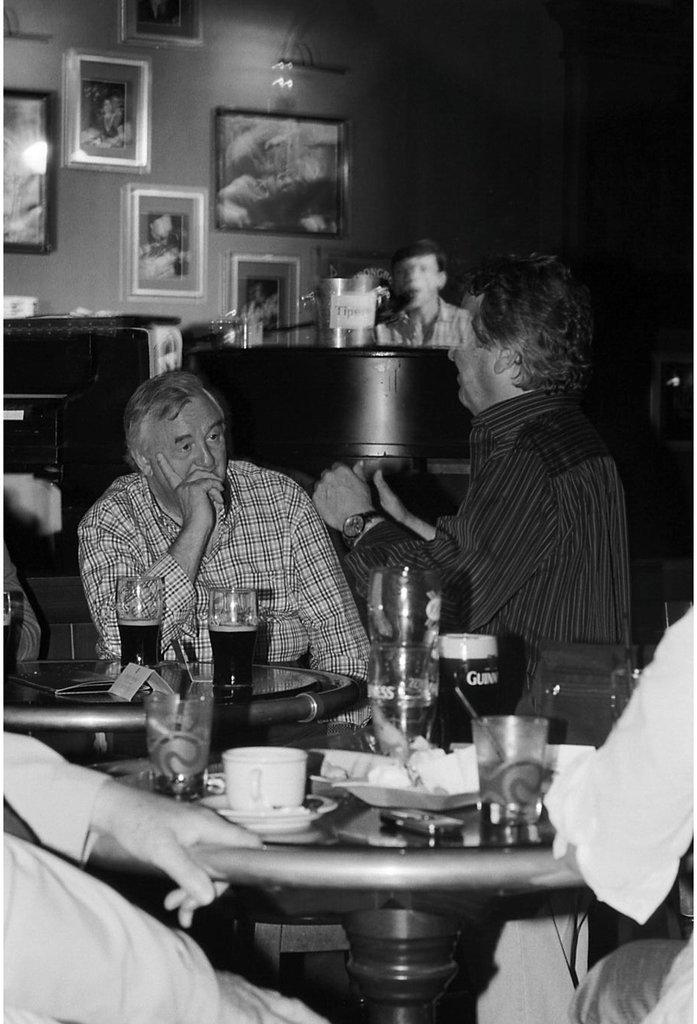What is the color scheme of the image? The image is black and white. Who or what can be seen in the image? There are people in the image. What type of furniture is present in the image? There are tables in the image. What is hanging on the walls in the image? There are pictures on the walls. What types of containers are on the tables in the image? On the tables, there are glasses and cups. What electronic devices are on the tables in the image? On the tables, there are mobile phones. What other objects can be seen on the tables in the image? There are other objects on the tables. What type of clouds can be seen in the image? There are no clouds visible in the image, as it is black and white and does not depict an outdoor scene. What is the wall is made of in the image? The provided facts do not mention the material of the wall, so it cannot be determined from the image. 